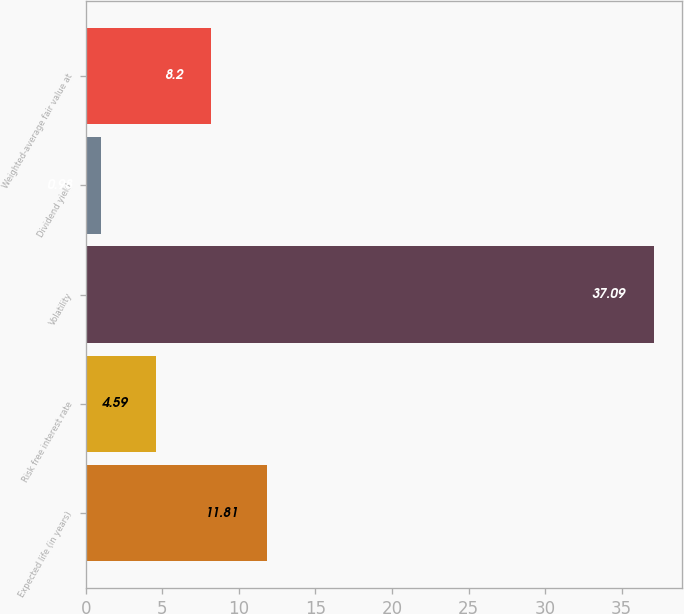Convert chart to OTSL. <chart><loc_0><loc_0><loc_500><loc_500><bar_chart><fcel>Expected life (in years)<fcel>Risk free interest rate<fcel>Volatility<fcel>Dividend yield<fcel>Weighted-average fair value at<nl><fcel>11.81<fcel>4.59<fcel>37.09<fcel>0.98<fcel>8.2<nl></chart> 